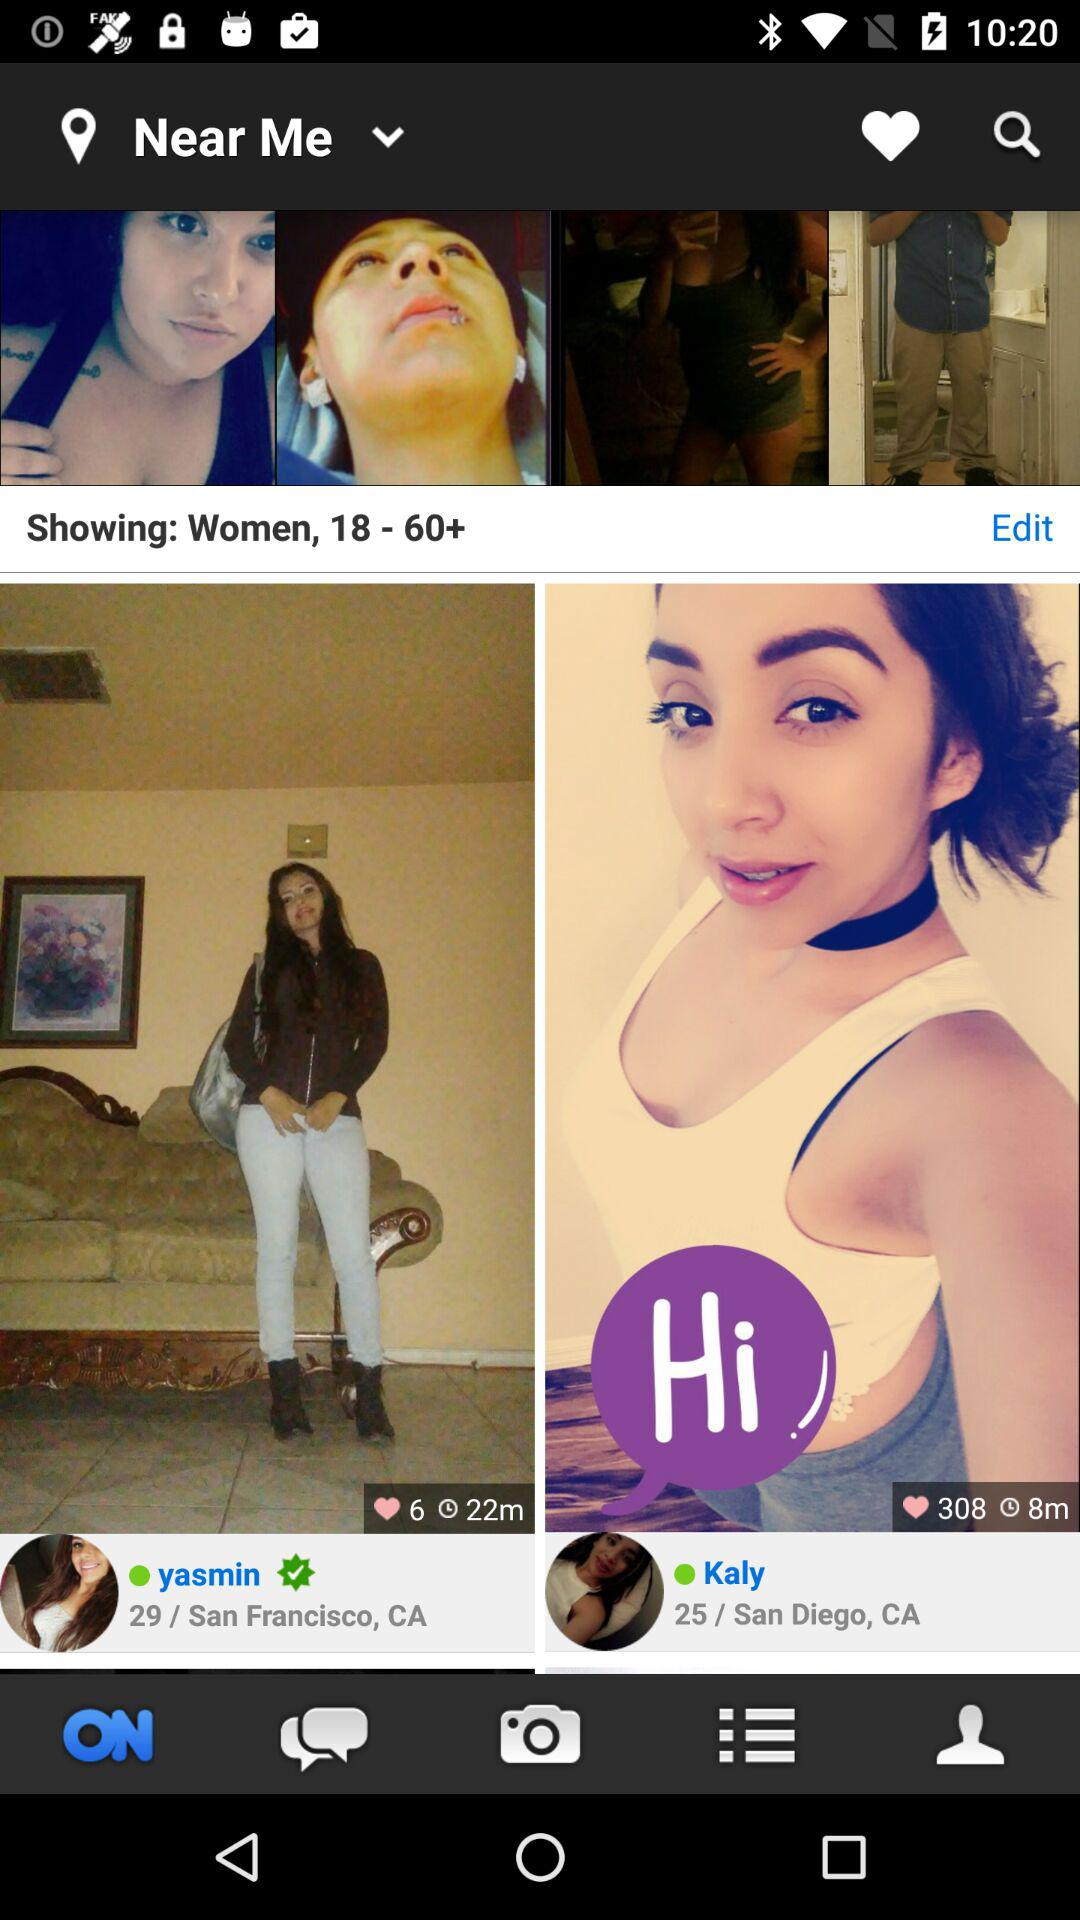What is the age of Kaly? Kaly is 25 years old. 